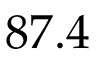Convert formula to latex. <formula><loc_0><loc_0><loc_500><loc_500>8 7 . 4</formula> 